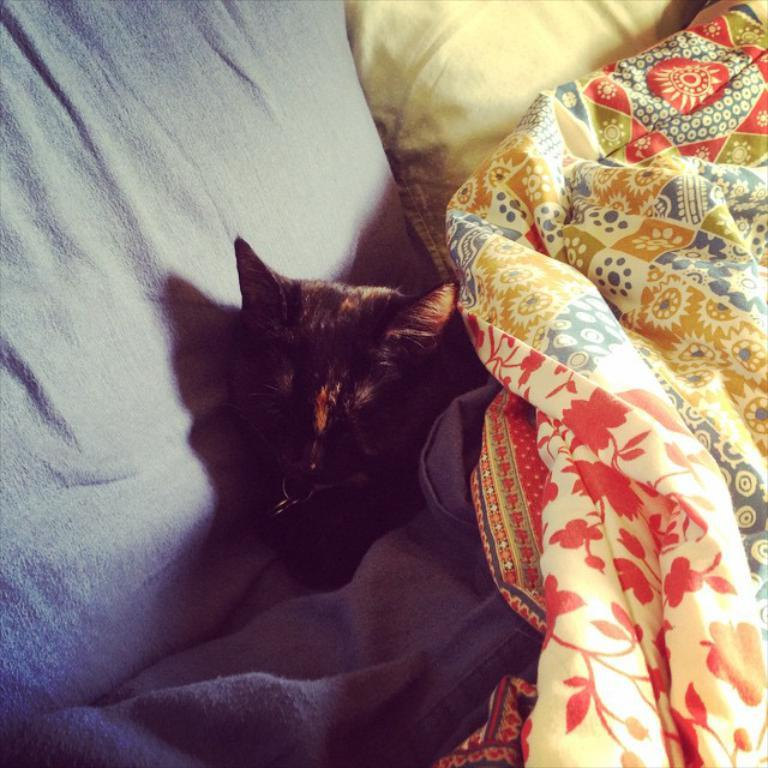What type of animal is in the image? There is a cat in the image. What is the cat doing in the image? The cat is sleeping on the bed. How many pillows are on the bed in the image? There are two pillows on the bed. How many blankets are on the bed in the image? There are two blankets on the bed. What type of power source is visible in the image? There is no power source visible in the image; it features a cat sleeping on a bed with pillows and blankets. 